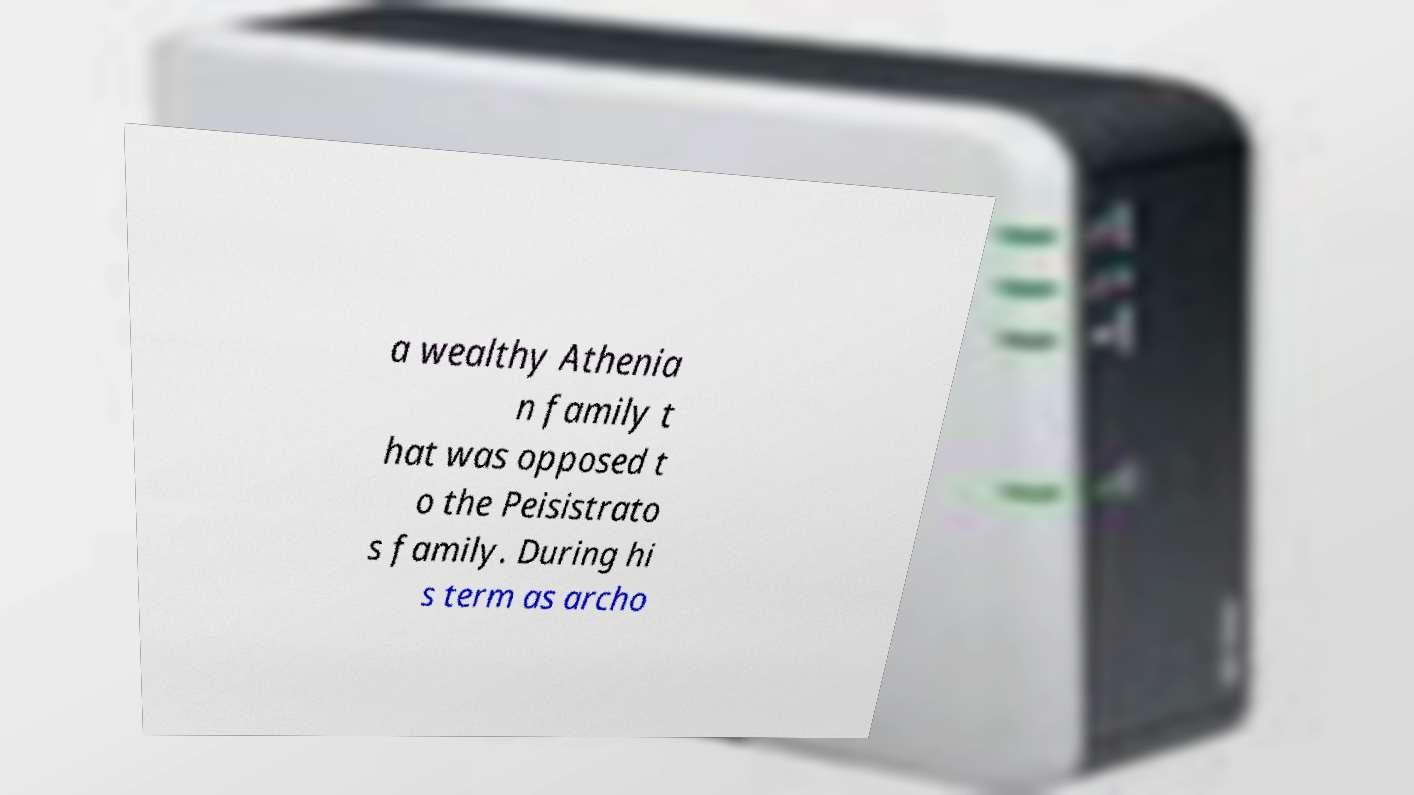Please read and relay the text visible in this image. What does it say? a wealthy Athenia n family t hat was opposed t o the Peisistrato s family. During hi s term as archo 